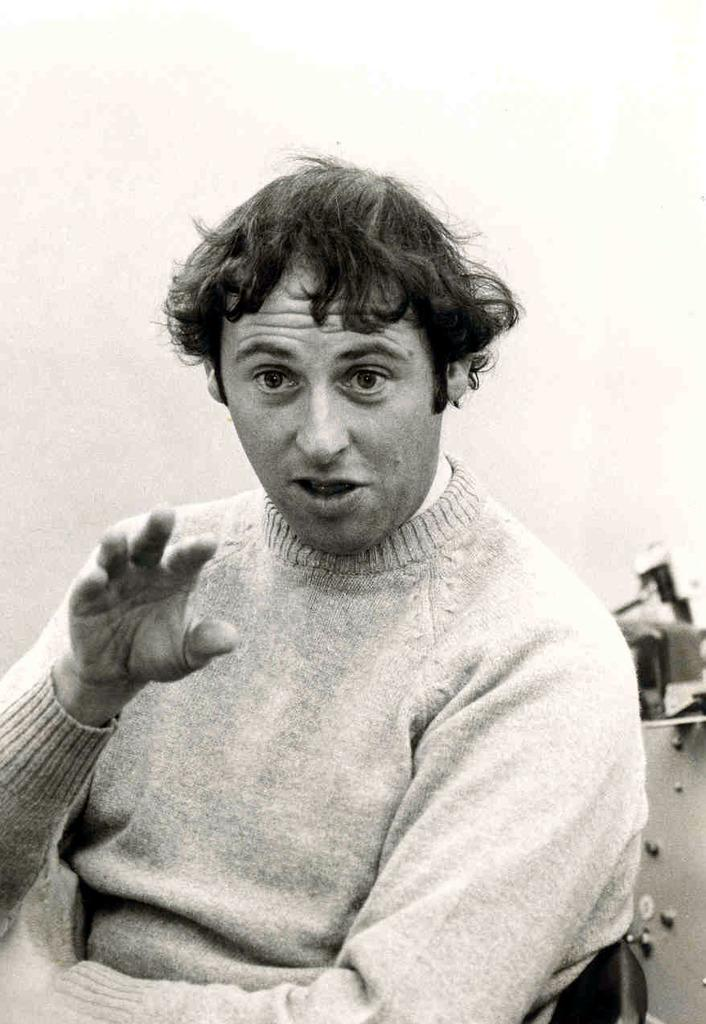What is the color scheme of the image? The image is black and white. Can you describe the main subject of the image? There is a person in the image. How many fingers does the person have in the image? There is no information about the number of fingers the person has in the image, as it is in black and white and does not provide such detail. 